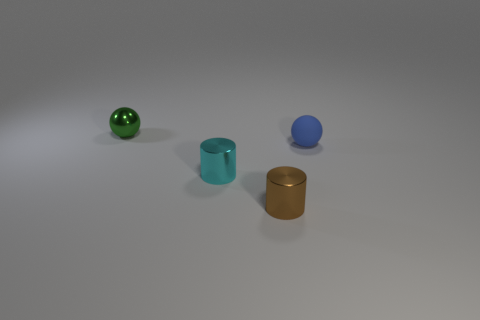Add 4 green balls. How many objects exist? 8 Subtract all green balls. Subtract all green metallic cylinders. How many objects are left? 3 Add 2 tiny metal things. How many tiny metal things are left? 5 Add 1 yellow rubber balls. How many yellow rubber balls exist? 1 Subtract 0 gray cubes. How many objects are left? 4 